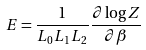Convert formula to latex. <formula><loc_0><loc_0><loc_500><loc_500>E = \frac { 1 } { L _ { 0 } L _ { 1 } L _ { 2 } } \frac { \partial \log Z } { \partial \beta }</formula> 